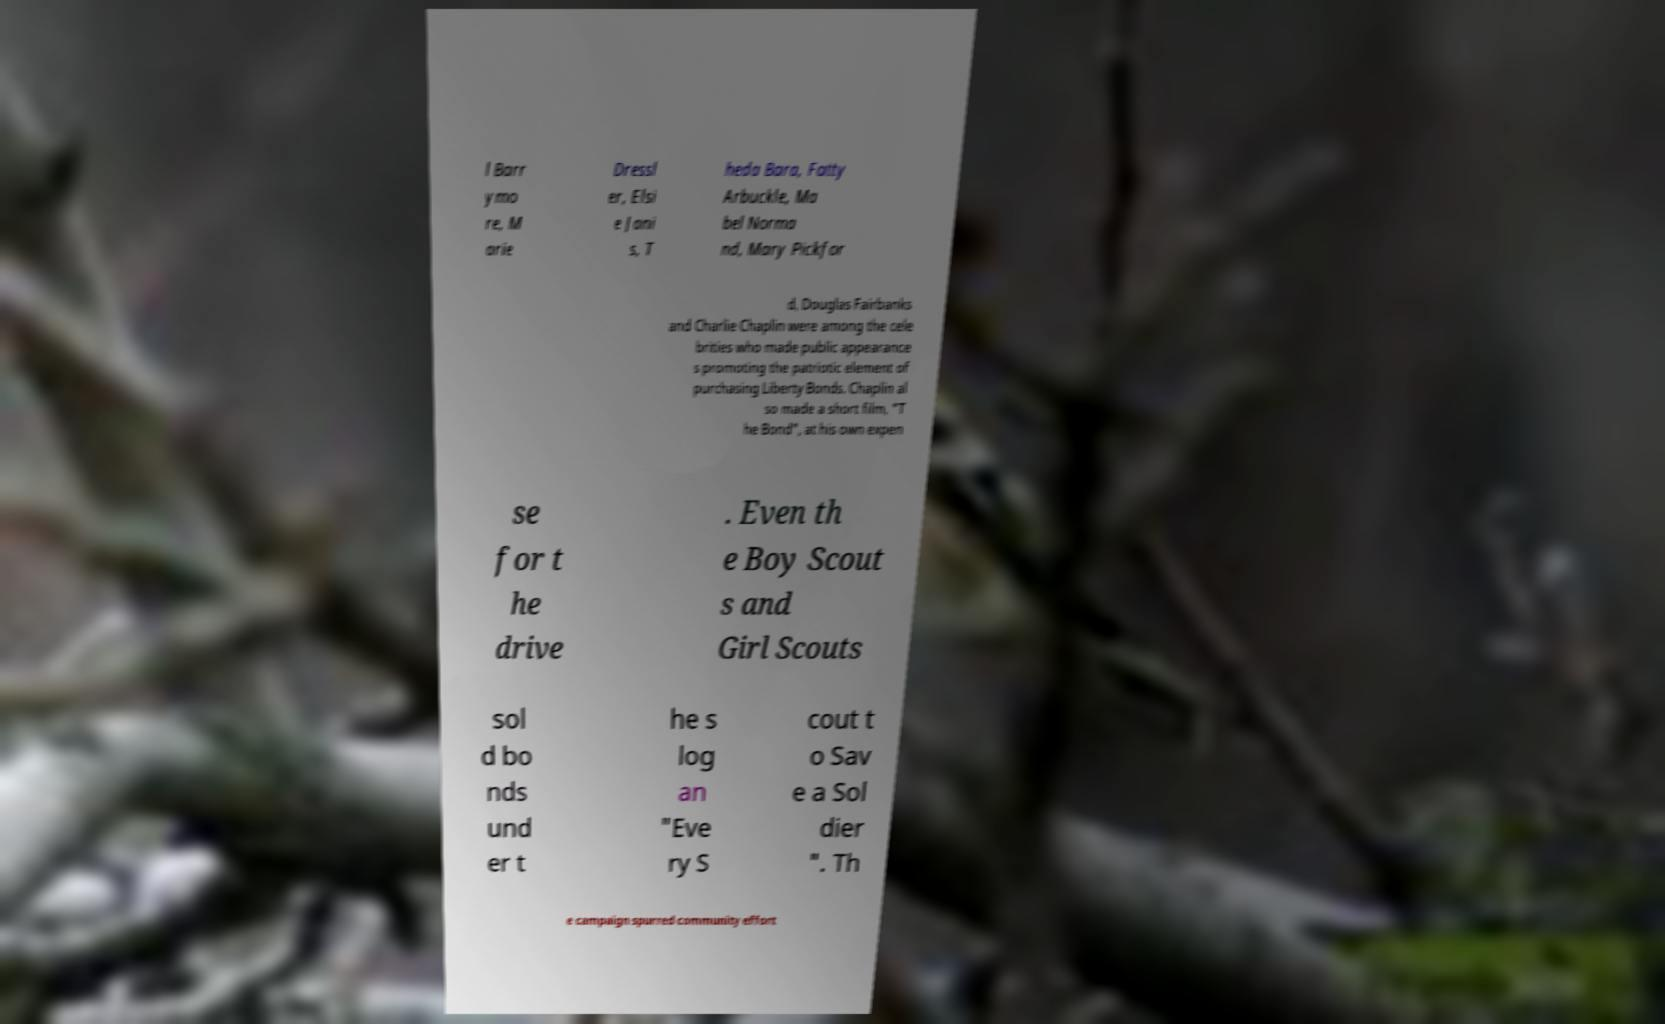Please read and relay the text visible in this image. What does it say? l Barr ymo re, M arie Dressl er, Elsi e Jani s, T heda Bara, Fatty Arbuckle, Ma bel Norma nd, Mary Pickfor d, Douglas Fairbanks and Charlie Chaplin were among the cele brities who made public appearance s promoting the patriotic element of purchasing Liberty Bonds. Chaplin al so made a short film, "T he Bond", at his own expen se for t he drive . Even th e Boy Scout s and Girl Scouts sol d bo nds und er t he s log an "Eve ry S cout t o Sav e a Sol dier ". Th e campaign spurred community effort 